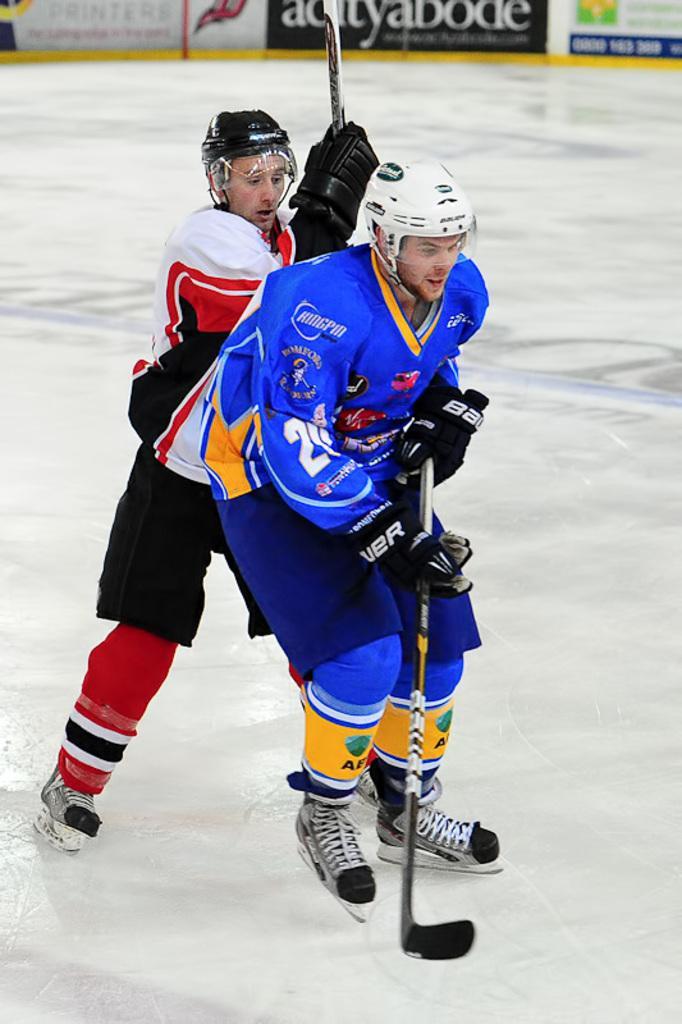In one or two sentences, can you explain what this image depicts? In the center of the image we can see two persons are ice skating. And they are holding sticks and they are wearing helmets and jackets. In the background we can see banners and a few other objects. 